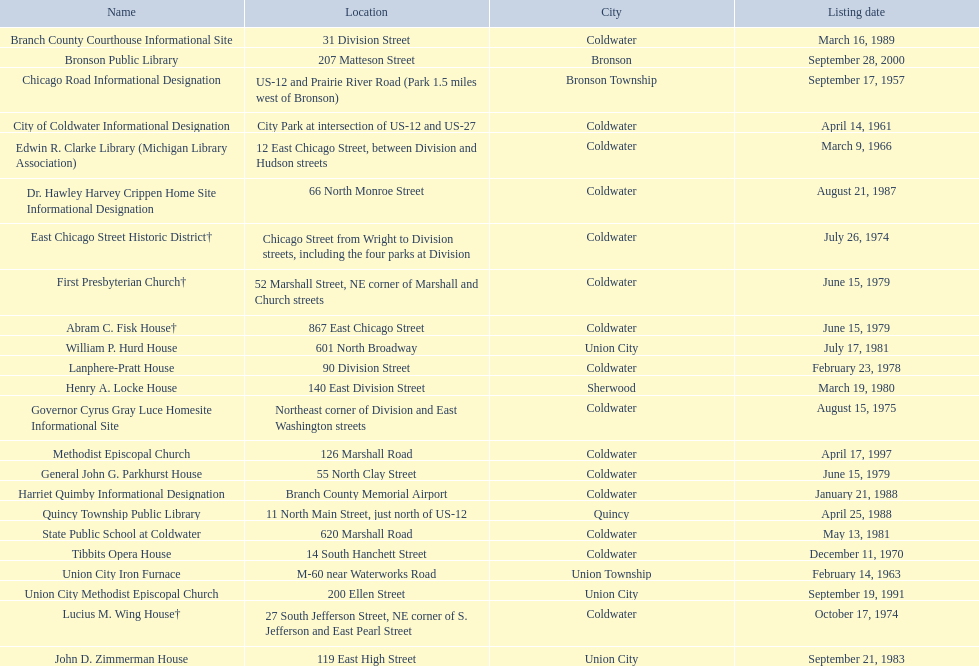Are there any listing dates that happened before 1960? September 17, 1957. What is the name of the site that was listed before 1960? Chicago Road Informational Designation. 